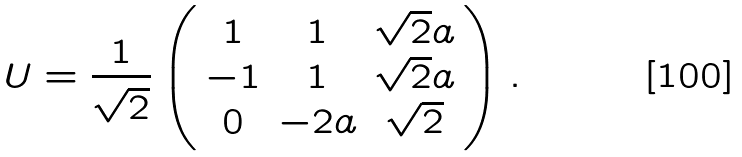Convert formula to latex. <formula><loc_0><loc_0><loc_500><loc_500>U = \frac { 1 } { \sqrt { 2 } } \left ( \begin{array} { c c c } 1 & 1 & \sqrt { 2 } a \\ - 1 & 1 & \sqrt { 2 } a \\ 0 & - 2 a & \sqrt { 2 } \end{array} \right ) .</formula> 